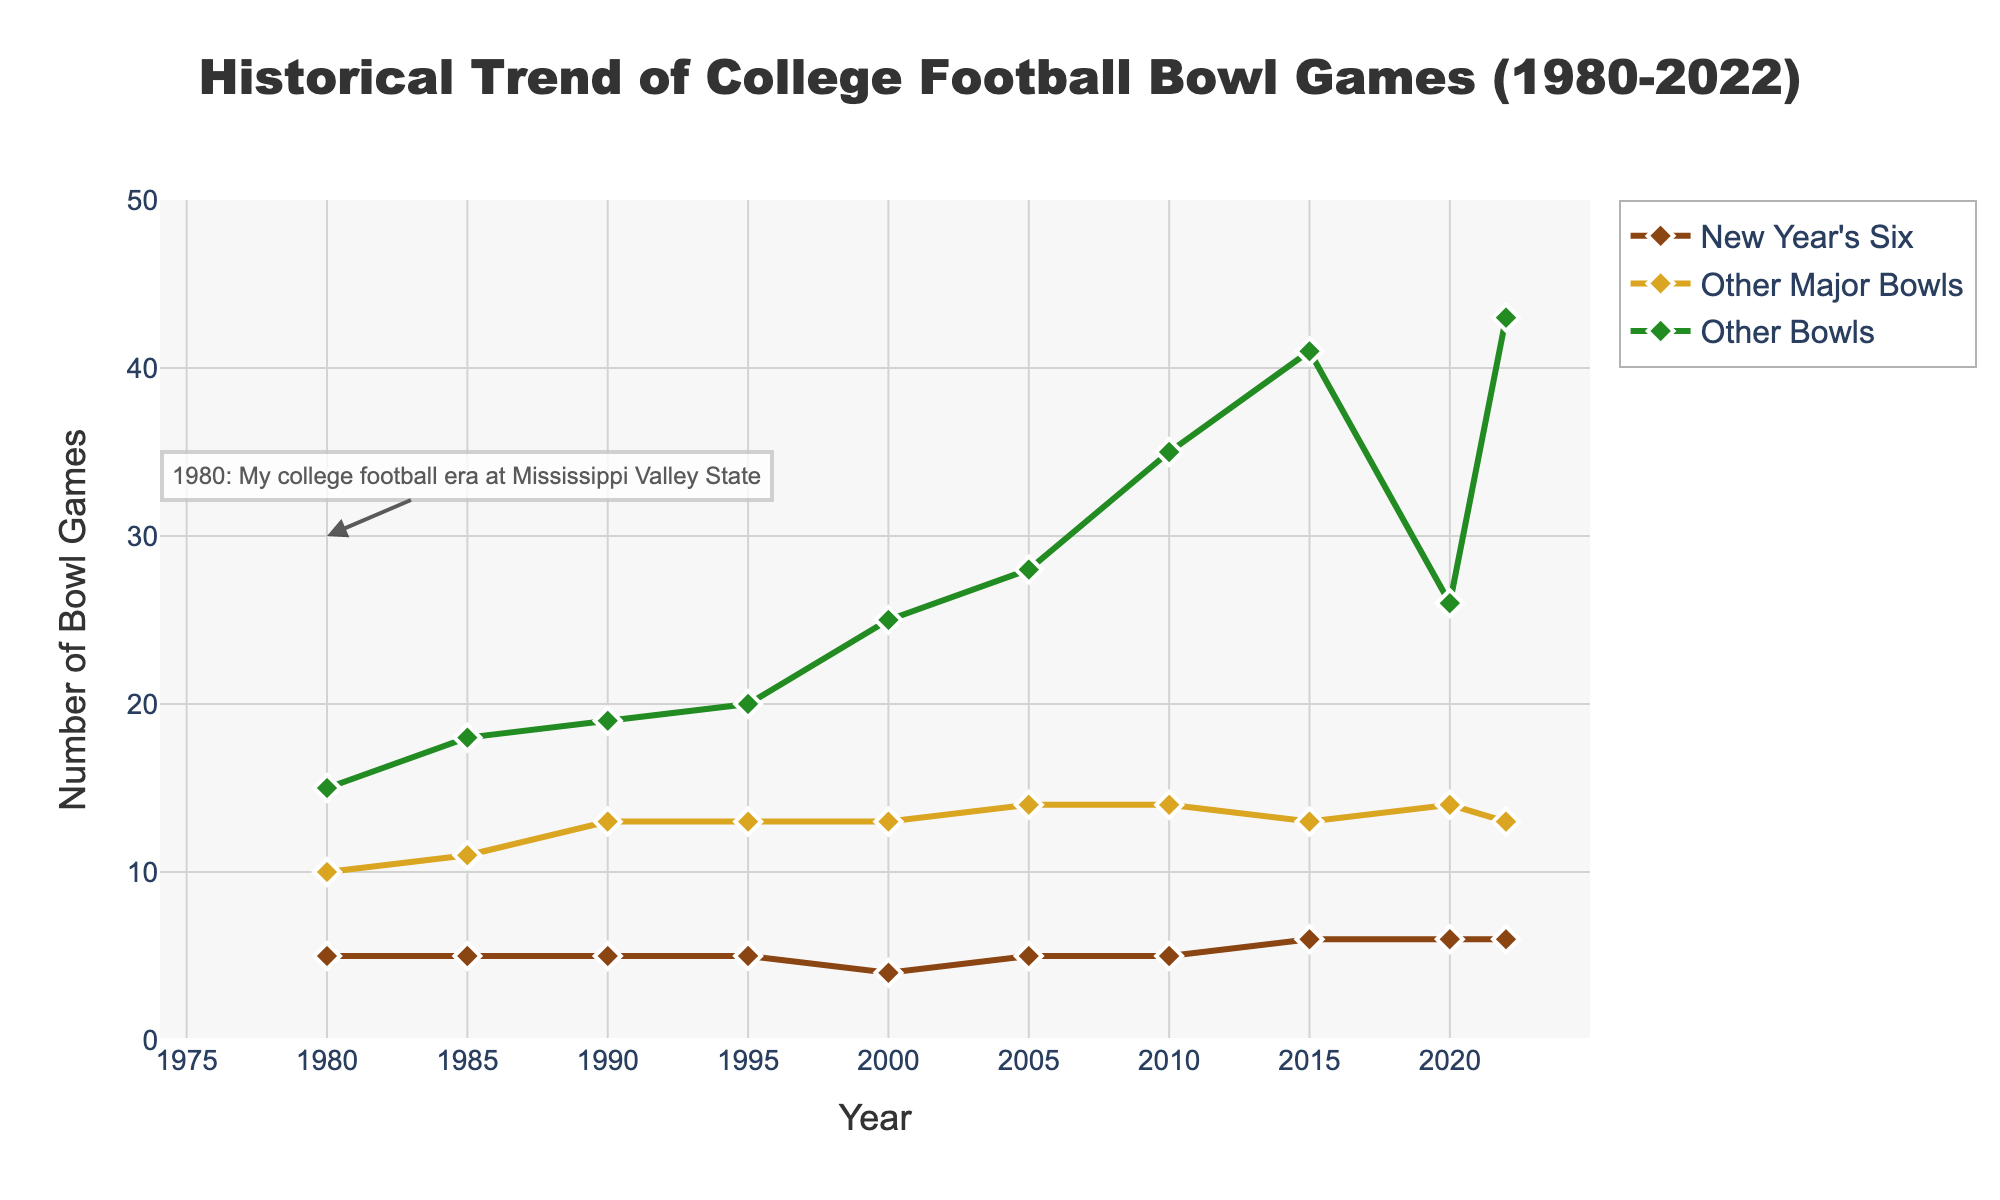what is the total number of bowl games in 1980? Add the New Year's Six, Other Major Bowls, and Other Bowls for 1980: 5 + 10 + 15 = 30.
Answer: 30 How many New Year's Six games were there in 2022 compared to 1980? Look at the number of New Year's Six games in 2022 (6) and in 1980 (5). Subtract to find the difference: 6 - 5 = 1.
Answer: 1 Which year had the highest total number of bowl games? Sum up the columns for each year and find the maximum total: 1980=30, 1985=34, 1990=37, 1995=38, 2000=42, 2005=47, 2010=54, 2015=60, 2020=46, 2022=62. The highest is 2022.
Answer: 2022 Did the number of Other Major Bowls change from 1980 to 2022? Compare the number of Other Major Bowls in 1980 (10) and in 2022 (13).
Answer: Yes What is the trend for the number of Other Bowls from 2000 to 2022? Observe the values of Other Bowls from 2000 to 2022: 25 (2000), 28 (2005), 35 (2010), 41 (2015), 26 (2020), 43 (2022). It increases overall, with a drop in 2020.
Answer: Increasing overall Which category had the smallest number of games in 2000? Compare the values for each category in 2000: New Year's Six (4), Other Major Bowls (13), Other Bowls (25). New Year's Six had the smallest number.
Answer: New Year's Six By how much did the total number of Other Bowls increase from 1980 to 2022? Subtract the number of Other Bowls in 1980 (15) from the number in 2022 (43): 43 - 15 = 28.
Answer: 28 In which year did the number of New Year's Six games have a sudden drop, and by how much? Check the New Year's Six values from 1980 to 2022: 5 (1980, 1985, 1990, 1995), 4 (2000). The sudden drop happened in 2000 by 1 game (5-4).
Answer: 2000, 1 Was there any year when the New Year’s Six games increased by more than one game compared to the previous period? Compare year by year changes for New Year’s Six: No such increases are observed.
Answer: No When did the number of other major bowls first reach 14? Find the year when Other Major Bowls first hit 14: It occurred in 2005.
Answer: 2005 